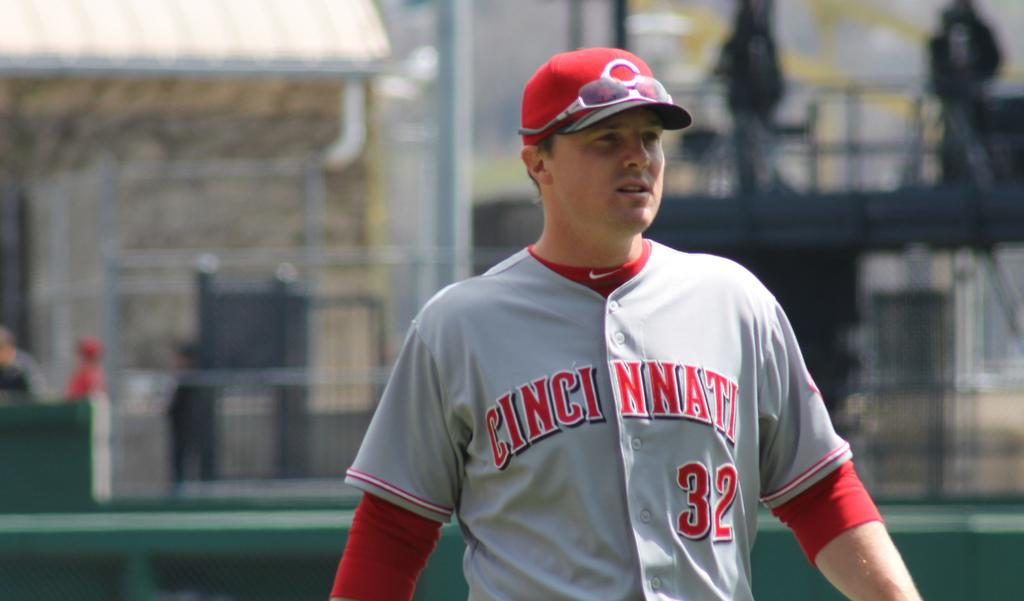<image>
Present a compact description of the photo's key features. Player number 32 from the Cincinnati Reds is shown wearing sunglasses on his cap. 